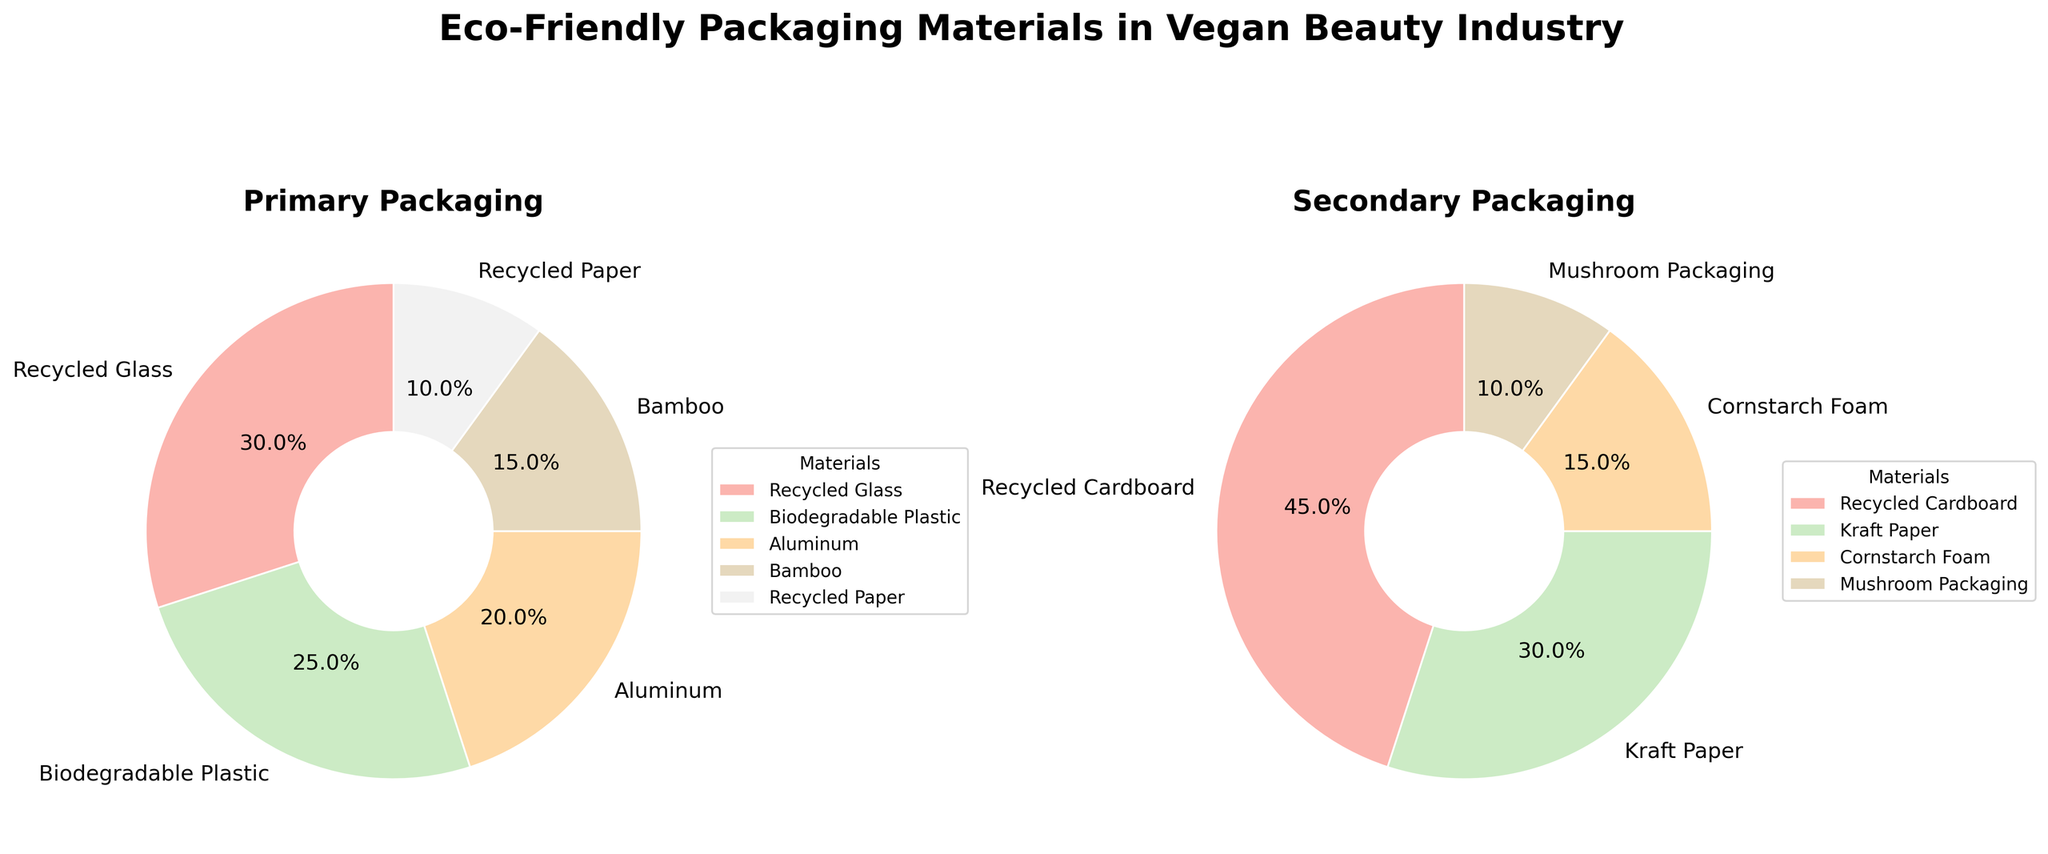What are the two main categories of packaging materials shown in the figure? The figure is split into two sections, one titled "Primary Packaging" and the other titled "Secondary Packaging". These titles are clearly shown above each pie chart.
Answer: Primary Packaging, Secondary Packaging Which material has the highest percentage in primary packaging? The primary packaging pie chart shows five materials: Recycled Glass, Biodegradable Plastic, Aluminum, Bamboo, and Recycled Paper. Among these, Recycled Glass has the largest slice of the pie chart, which corresponds to the highest percentage.
Answer: Recycled Glass What is the combined percentage of Biodegradable Plastic and Recycled Paper in primary packaging? To find the combined percentage, add the percentages of Biodegradable Plastic (25%) and Recycled Paper (10%) from the primary packaging pie chart: 25% + 10% = 35%.
Answer: 35% Which packaging material is used more, Aluminum in primary packaging or Kraft Paper in secondary packaging? By comparing the pie charts, Aluminum in primary packaging is 20%, and Kraft Paper in secondary packaging is 30%. Since 30% is greater than 20%, Kraft Paper is used more.
Answer: Kraft Paper List the materials in secondary packaging in order from highest percentage to lowest. The secondary packaging pie chart categories are: Recycled Cardboard (45%), Kraft Paper (30%), Cornstarch Foam (15%), and Mushroom Packaging (10%). Arranging them from highest to lowest: 45%, 30%, 15%, and 10%.
Answer: Recycled Cardboard, Kraft Paper, Cornstarch Foam, Mushroom Packaging What is the total percentage of non-biodegradable materials used in primary packaging? The primary packaging pie chart includes Recycled Glass (30%), Aluminum (20%), and Recycled Paper (10%). Since these materials are non-biodegradable, their sum is 30% + 20% + 10% = 60%.
Answer: 60% Which material is the least used in both categories combined? The smallest segment in both pie charts is the Mushroom Packaging in the secondary packaging, which occupies 10% of the chart. Since there is no smaller segment in primary packaging, Mushroom Packaging has the least use overall.
Answer: Mushroom Packaging Compare the percentage of Bamboo used in primary packaging to Cornstarch Foam in secondary packaging. Which is higher and by how much? Bamboo in primary packaging is 15%, and Cornstarch Foam in secondary packaging is also 15%. They are equal in percentage.
Answer: Equal What percentage of the secondary packaging is made from materials derived from plants? The plant-derived materials in secondary packaging are Kraft Paper (30%) and Cornstarch Foam (15%). Their total combined is 30% + 15% = 45%.
Answer: 45% 